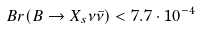Convert formula to latex. <formula><loc_0><loc_0><loc_500><loc_500>B r ( B \to X _ { s } \nu \bar { \nu } ) < 7 . 7 \cdot 1 0 ^ { - 4 }</formula> 